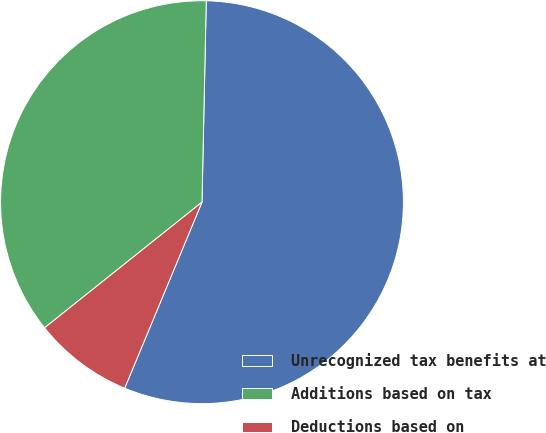<chart> <loc_0><loc_0><loc_500><loc_500><pie_chart><fcel>Unrecognized tax benefits at<fcel>Additions based on tax<fcel>Deductions based on<nl><fcel>55.93%<fcel>36.06%<fcel>8.01%<nl></chart> 